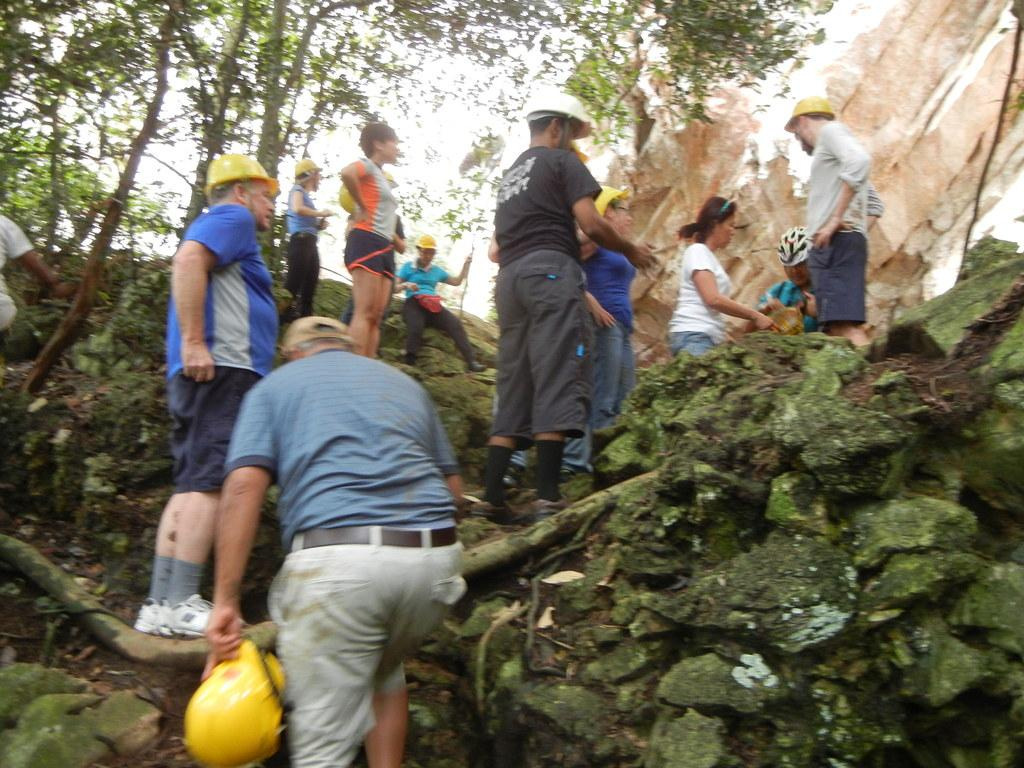What are the people in the image doing? There are people standing in the image, and one person is walking. What is the person walking holding? The person walking is holding a helmet. What type of terrain can be seen in the image? There are rocks visible in the image. What type of vegetation is present in the image? There are trees in the image. What is visible in the background of the image? The sky is visible in the image. What type of legal advice is the lawyer giving to the bears in the image? There is no lawyer or bears present in the image. What type of surface are the people walking on in the image? The image does not show a sidewalk; it only shows rocks and trees. 